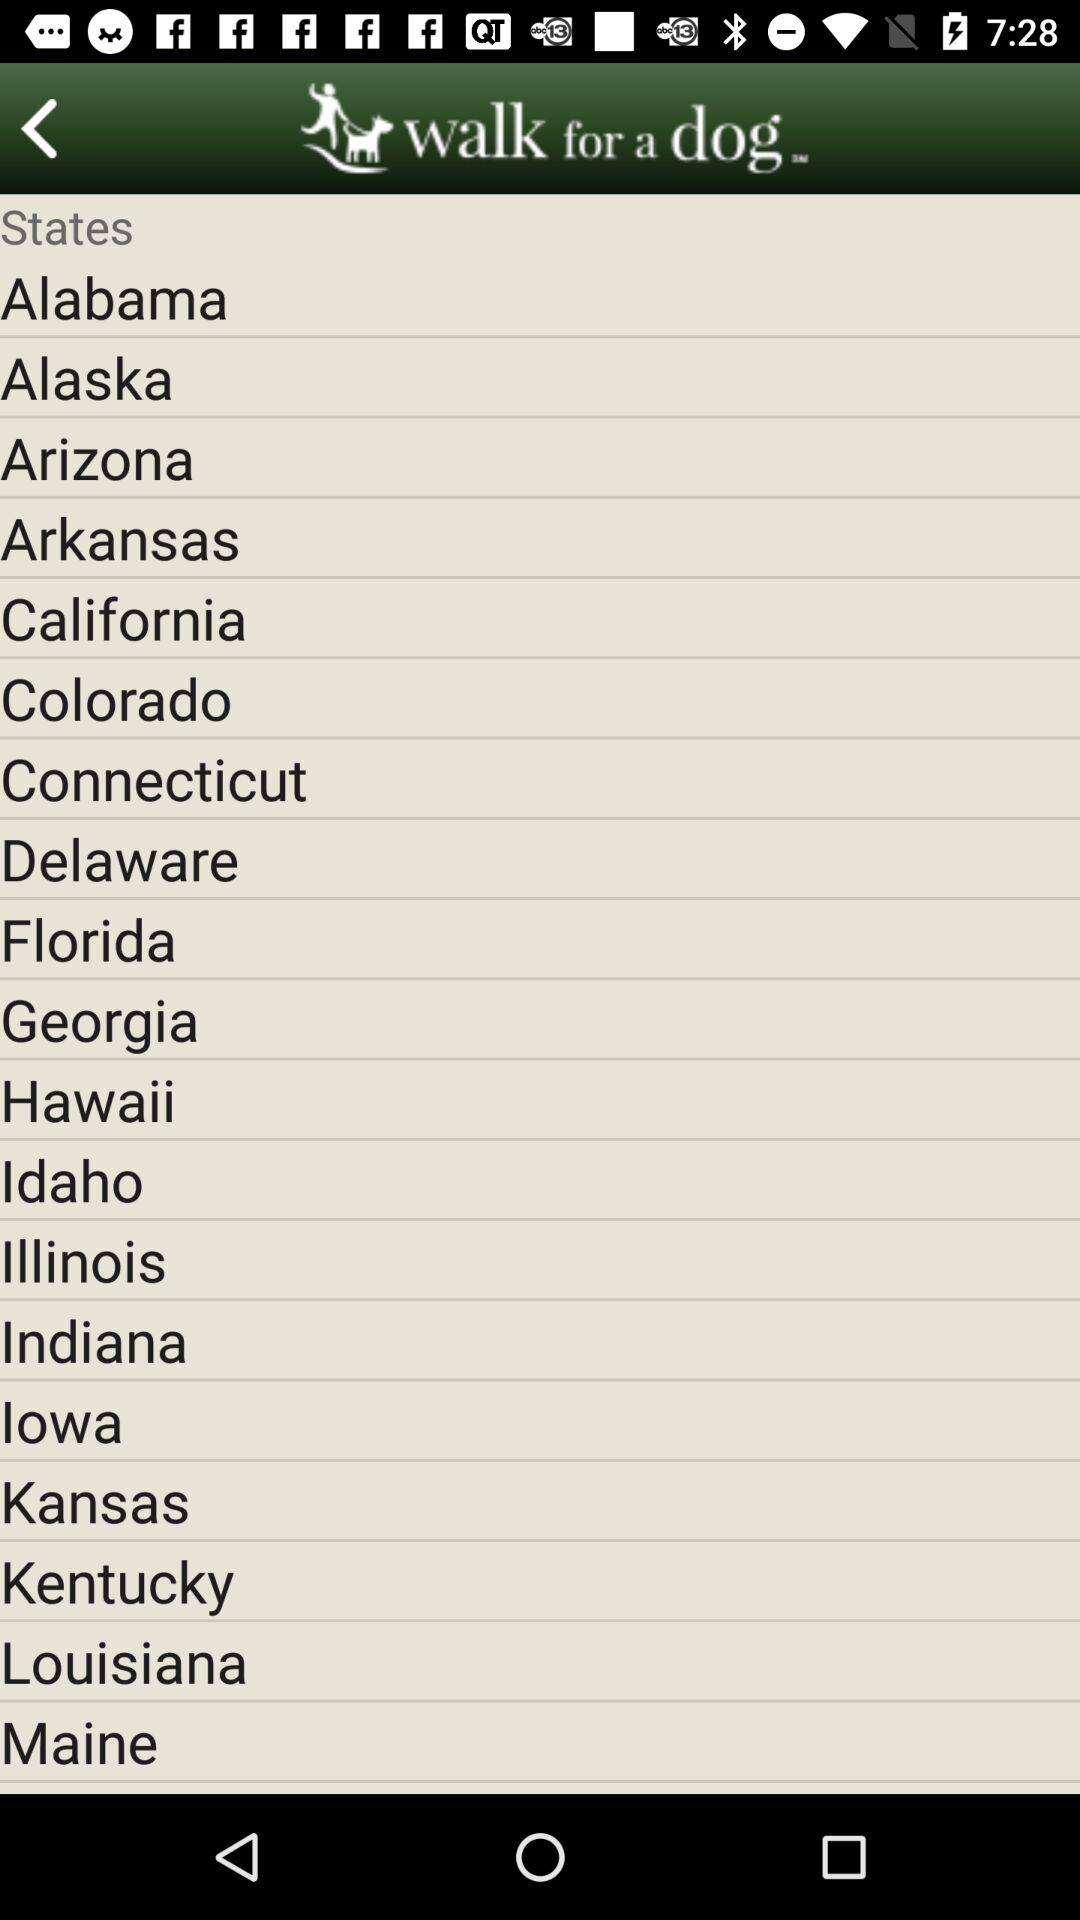What is the selected state?
When the provided information is insufficient, respond with <no answer>. <no answer> 